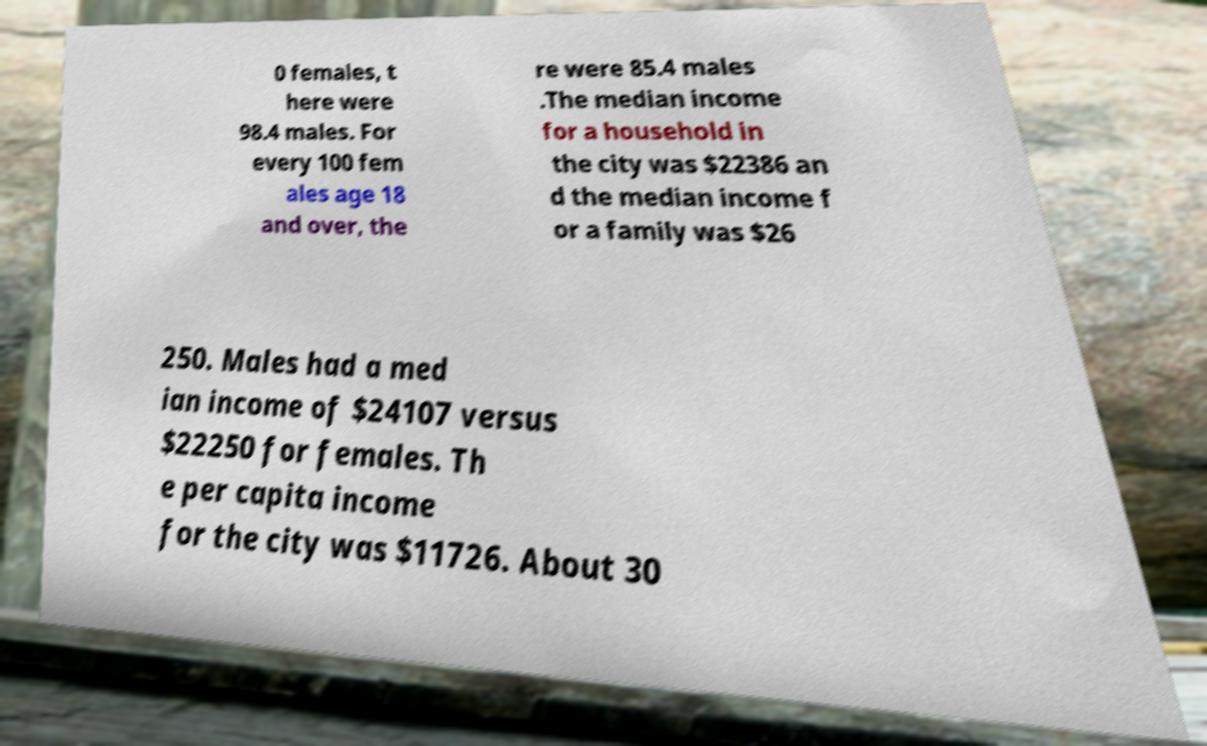Can you read and provide the text displayed in the image?This photo seems to have some interesting text. Can you extract and type it out for me? 0 females, t here were 98.4 males. For every 100 fem ales age 18 and over, the re were 85.4 males .The median income for a household in the city was $22386 an d the median income f or a family was $26 250. Males had a med ian income of $24107 versus $22250 for females. Th e per capita income for the city was $11726. About 30 